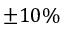Convert formula to latex. <formula><loc_0><loc_0><loc_500><loc_500>\pm 1 0 \%</formula> 